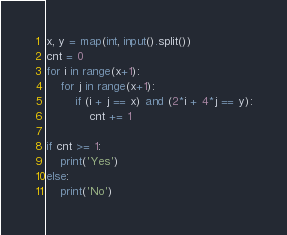<code> <loc_0><loc_0><loc_500><loc_500><_Python_>x, y = map(int, input().split())
cnt = 0
for i in range(x+1):
    for j in range(x+1):
        if (i + j == x) and (2*i + 4*j == y):
            cnt += 1
                
if cnt >= 1:
    print('Yes')
else:
    print('No')</code> 